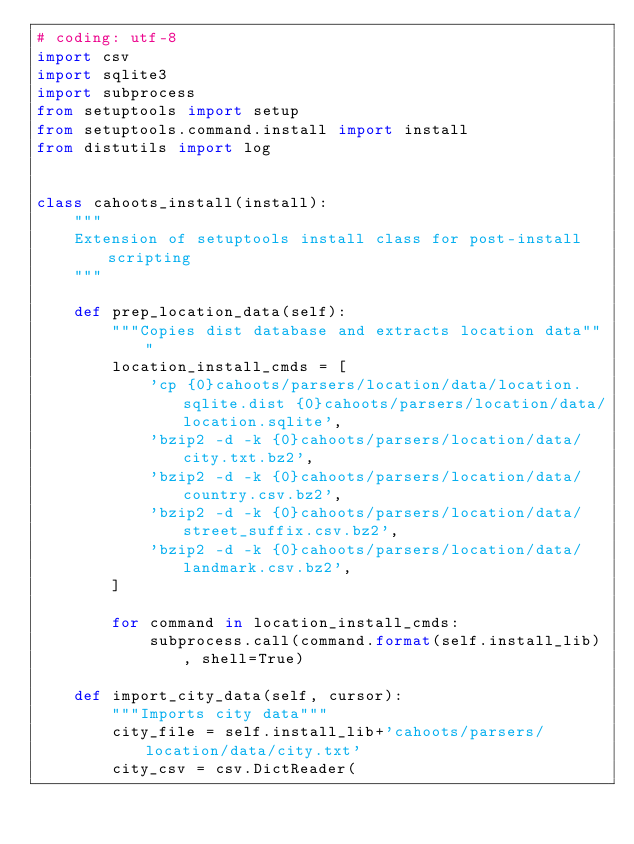<code> <loc_0><loc_0><loc_500><loc_500><_Python_># coding: utf-8
import csv
import sqlite3
import subprocess
from setuptools import setup
from setuptools.command.install import install
from distutils import log


class cahoots_install(install):
    """
    Extension of setuptools install class for post-install scripting
    """

    def prep_location_data(self):
        """Copies dist database and extracts location data"""
        location_install_cmds = [
            'cp {0}cahoots/parsers/location/data/location.sqlite.dist {0}cahoots/parsers/location/data/location.sqlite',
            'bzip2 -d -k {0}cahoots/parsers/location/data/city.txt.bz2',
            'bzip2 -d -k {0}cahoots/parsers/location/data/country.csv.bz2',
            'bzip2 -d -k {0}cahoots/parsers/location/data/street_suffix.csv.bz2',
            'bzip2 -d -k {0}cahoots/parsers/location/data/landmark.csv.bz2',
        ]

        for command in location_install_cmds:
            subprocess.call(command.format(self.install_lib), shell=True)

    def import_city_data(self, cursor):
        """Imports city data"""
        city_file = self.install_lib+'cahoots/parsers/location/data/city.txt'
        city_csv = csv.DictReader(</code> 